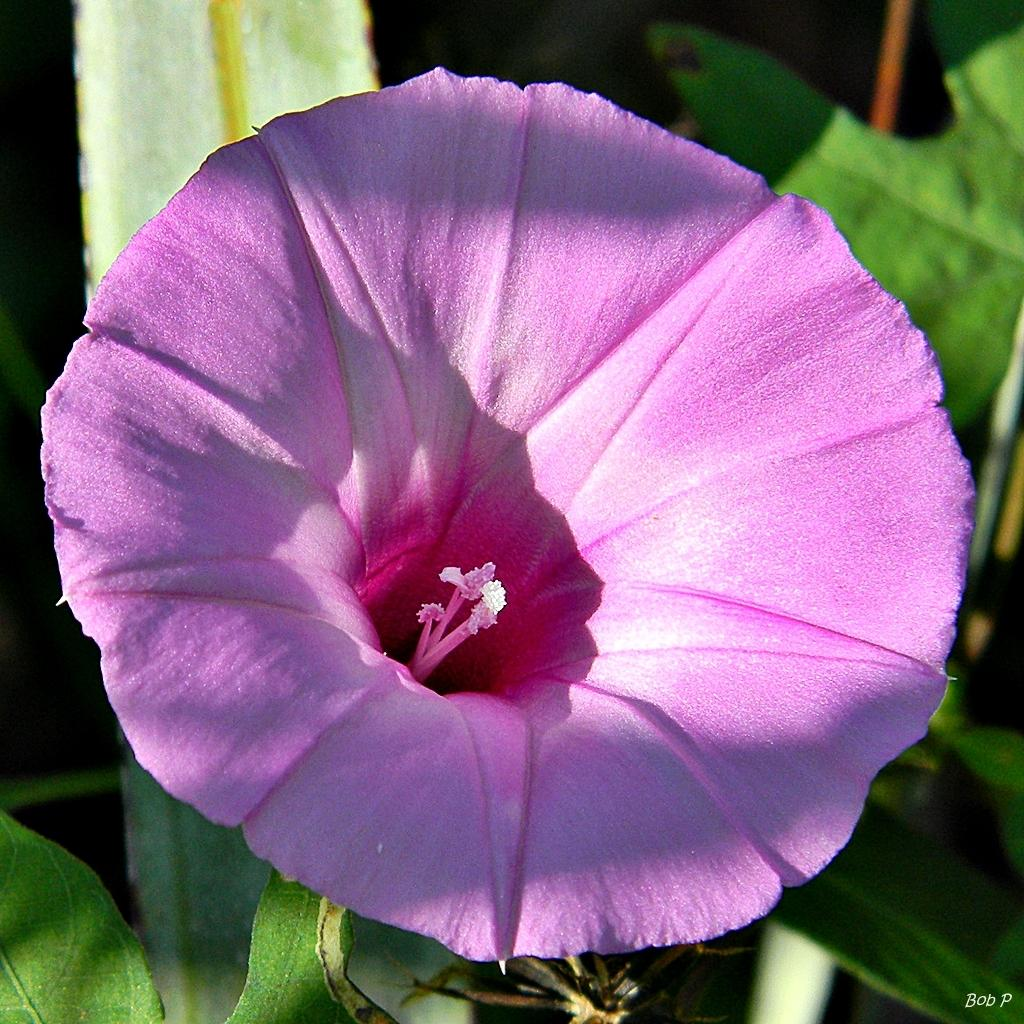What is the main subject of the image? There is a flower in the image. What can be seen in the background of the image? There are leaves in the background of the image. How does the flower start its vacation in the image? The flower does not go on vacation in the image, as it is a still image and not a representation of a living organism's actions. 